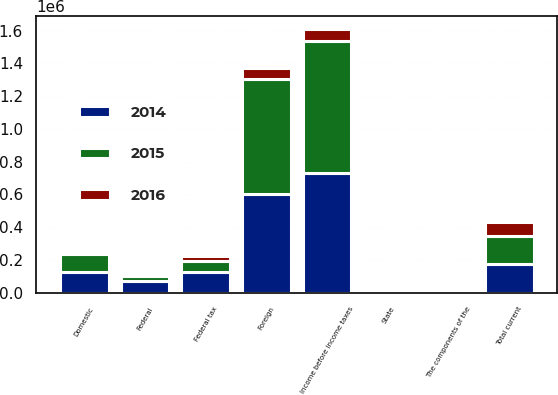Convert chart. <chart><loc_0><loc_0><loc_500><loc_500><stacked_bar_chart><ecel><fcel>Domestic<fcel>Foreign<fcel>Income before income taxes<fcel>The components of the<fcel>Federal tax<fcel>State<fcel>Total current<fcel>Federal<nl><fcel>2016<fcel>2642<fcel>70102.5<fcel>70102.5<fcel>2016<fcel>27790<fcel>1409<fcel>87133<fcel>325<nl><fcel>2015<fcel>110710<fcel>699404<fcel>810114<fcel>2015<fcel>65942<fcel>695<fcel>165450<fcel>27933<nl><fcel>2014<fcel>127084<fcel>602261<fcel>729345<fcel>2014<fcel>128591<fcel>316<fcel>177736<fcel>74263<nl></chart> 